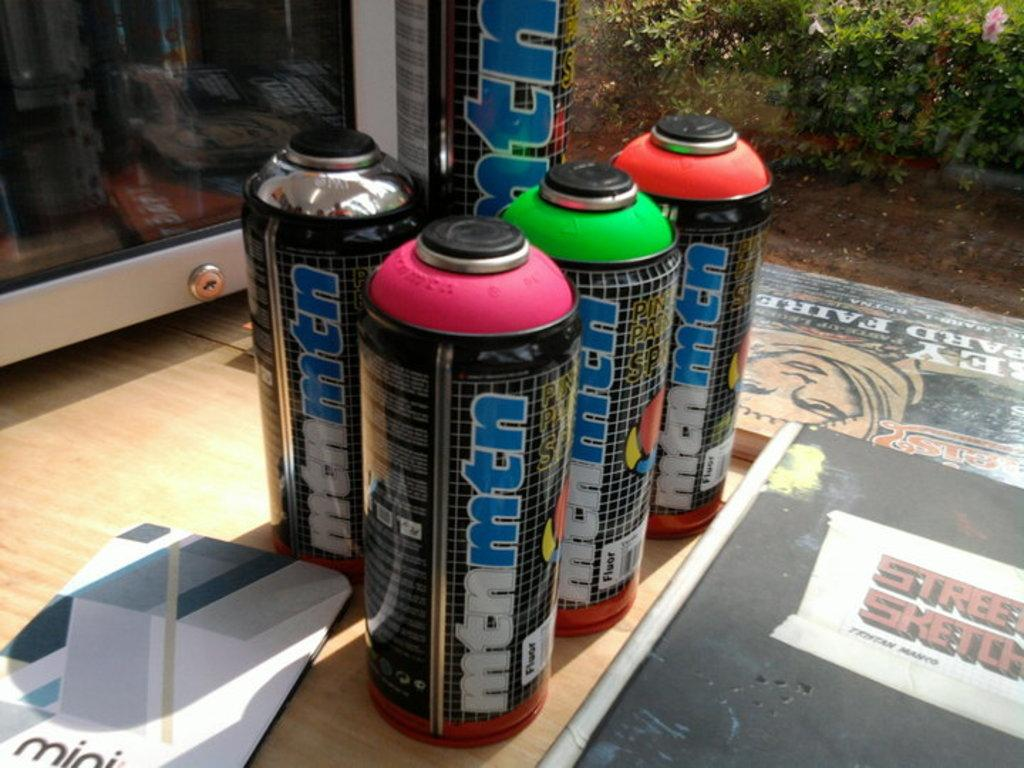<image>
Create a compact narrative representing the image presented. Bottles on the floor named mtnmtn next to one another. 